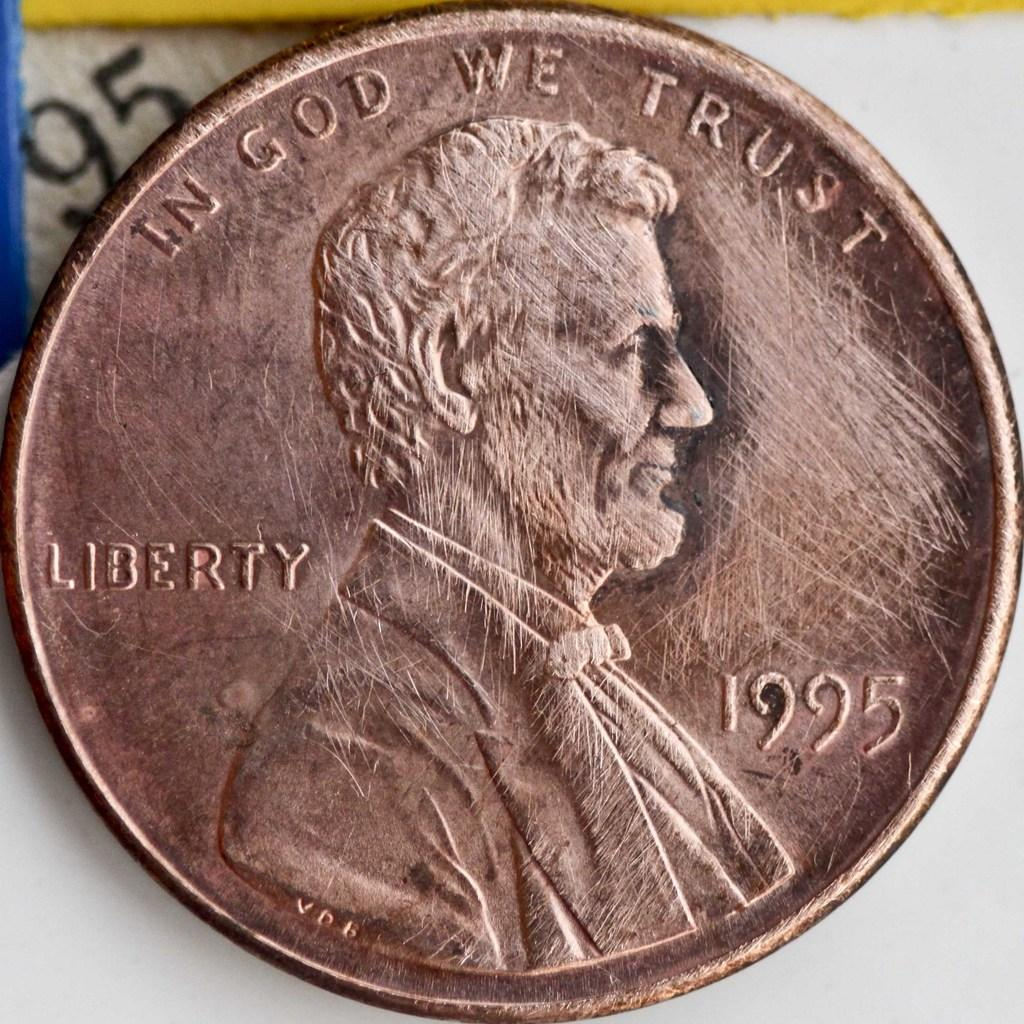<image>
Give a short and clear explanation of the subsequent image. A penny from 1995 is on a table with In God We Trust written on top. 